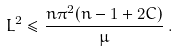<formula> <loc_0><loc_0><loc_500><loc_500>L ^ { 2 } \leq \frac { n \pi ^ { 2 } ( n - 1 + 2 C ) } { \mu } \, .</formula> 